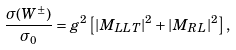Convert formula to latex. <formula><loc_0><loc_0><loc_500><loc_500>\frac { \sigma ( W ^ { \pm } ) } { \sigma _ { 0 } } = g ^ { 2 } \left [ | M _ { L L T } | ^ { 2 } + | M _ { R L } | ^ { 2 } \right ] ,</formula> 